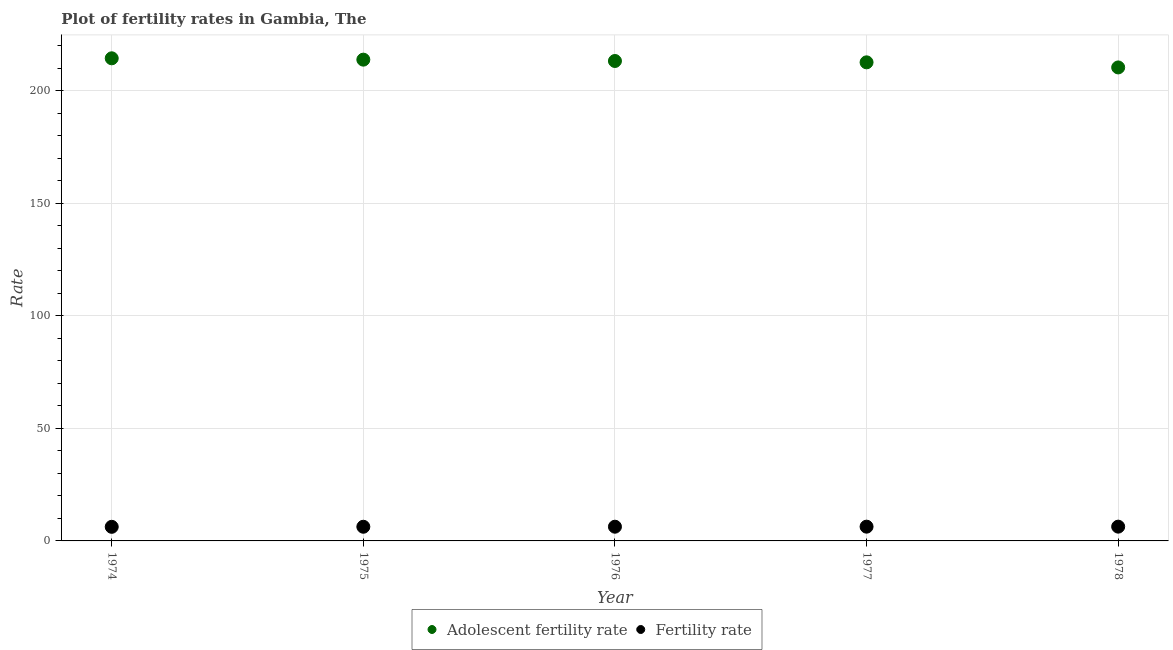How many different coloured dotlines are there?
Keep it short and to the point. 2. What is the adolescent fertility rate in 1975?
Ensure brevity in your answer.  213.81. Across all years, what is the maximum fertility rate?
Make the answer very short. 6.34. Across all years, what is the minimum adolescent fertility rate?
Ensure brevity in your answer.  210.35. In which year was the fertility rate maximum?
Keep it short and to the point. 1978. In which year was the adolescent fertility rate minimum?
Give a very brief answer. 1978. What is the total adolescent fertility rate in the graph?
Your answer should be compact. 1064.4. What is the difference between the fertility rate in 1975 and that in 1977?
Keep it short and to the point. -0.04. What is the difference between the fertility rate in 1975 and the adolescent fertility rate in 1976?
Keep it short and to the point. -206.92. What is the average fertility rate per year?
Your answer should be compact. 6.31. In the year 1978, what is the difference between the fertility rate and adolescent fertility rate?
Offer a very short reply. -204.01. What is the ratio of the fertility rate in 1976 to that in 1977?
Provide a short and direct response. 1. What is the difference between the highest and the second highest fertility rate?
Keep it short and to the point. 0.01. What is the difference between the highest and the lowest fertility rate?
Keep it short and to the point. 0.08. In how many years, is the adolescent fertility rate greater than the average adolescent fertility rate taken over all years?
Give a very brief answer. 3. Is the adolescent fertility rate strictly less than the fertility rate over the years?
Your answer should be very brief. No. What is the difference between two consecutive major ticks on the Y-axis?
Your answer should be compact. 50. Does the graph contain any zero values?
Provide a succinct answer. No. Does the graph contain grids?
Give a very brief answer. Yes. Where does the legend appear in the graph?
Provide a succinct answer. Bottom center. How are the legend labels stacked?
Offer a very short reply. Horizontal. What is the title of the graph?
Offer a terse response. Plot of fertility rates in Gambia, The. What is the label or title of the X-axis?
Give a very brief answer. Year. What is the label or title of the Y-axis?
Your answer should be very brief. Rate. What is the Rate of Adolescent fertility rate in 1974?
Your answer should be compact. 214.41. What is the Rate in Fertility rate in 1974?
Offer a terse response. 6.26. What is the Rate of Adolescent fertility rate in 1975?
Your answer should be very brief. 213.81. What is the Rate in Fertility rate in 1975?
Ensure brevity in your answer.  6.29. What is the Rate in Adolescent fertility rate in 1976?
Provide a short and direct response. 213.21. What is the Rate of Fertility rate in 1976?
Provide a short and direct response. 6.32. What is the Rate of Adolescent fertility rate in 1977?
Provide a short and direct response. 212.62. What is the Rate in Fertility rate in 1977?
Give a very brief answer. 6.33. What is the Rate in Adolescent fertility rate in 1978?
Offer a very short reply. 210.35. What is the Rate of Fertility rate in 1978?
Offer a very short reply. 6.34. Across all years, what is the maximum Rate of Adolescent fertility rate?
Make the answer very short. 214.41. Across all years, what is the maximum Rate of Fertility rate?
Ensure brevity in your answer.  6.34. Across all years, what is the minimum Rate of Adolescent fertility rate?
Provide a short and direct response. 210.35. Across all years, what is the minimum Rate of Fertility rate?
Your answer should be very brief. 6.26. What is the total Rate of Adolescent fertility rate in the graph?
Your answer should be compact. 1064.4. What is the total Rate of Fertility rate in the graph?
Your answer should be compact. 31.55. What is the difference between the Rate of Adolescent fertility rate in 1974 and that in 1975?
Your response must be concise. 0.6. What is the difference between the Rate of Fertility rate in 1974 and that in 1975?
Provide a short and direct response. -0.03. What is the difference between the Rate in Adolescent fertility rate in 1974 and that in 1976?
Provide a short and direct response. 1.2. What is the difference between the Rate in Fertility rate in 1974 and that in 1976?
Provide a short and direct response. -0.05. What is the difference between the Rate in Adolescent fertility rate in 1974 and that in 1977?
Offer a terse response. 1.79. What is the difference between the Rate in Fertility rate in 1974 and that in 1977?
Your response must be concise. -0.07. What is the difference between the Rate in Adolescent fertility rate in 1974 and that in 1978?
Provide a short and direct response. 4.06. What is the difference between the Rate of Fertility rate in 1974 and that in 1978?
Your answer should be very brief. -0.08. What is the difference between the Rate in Adolescent fertility rate in 1975 and that in 1976?
Provide a short and direct response. 0.6. What is the difference between the Rate in Fertility rate in 1975 and that in 1976?
Offer a very short reply. -0.02. What is the difference between the Rate of Adolescent fertility rate in 1975 and that in 1977?
Your response must be concise. 1.2. What is the difference between the Rate of Fertility rate in 1975 and that in 1977?
Your answer should be very brief. -0.04. What is the difference between the Rate in Adolescent fertility rate in 1975 and that in 1978?
Ensure brevity in your answer.  3.46. What is the difference between the Rate in Fertility rate in 1975 and that in 1978?
Make the answer very short. -0.05. What is the difference between the Rate of Adolescent fertility rate in 1976 and that in 1977?
Keep it short and to the point. 0.6. What is the difference between the Rate of Fertility rate in 1976 and that in 1977?
Your answer should be compact. -0.02. What is the difference between the Rate in Adolescent fertility rate in 1976 and that in 1978?
Ensure brevity in your answer.  2.86. What is the difference between the Rate in Fertility rate in 1976 and that in 1978?
Provide a short and direct response. -0.03. What is the difference between the Rate in Adolescent fertility rate in 1977 and that in 1978?
Your answer should be very brief. 2.26. What is the difference between the Rate in Fertility rate in 1977 and that in 1978?
Keep it short and to the point. -0.01. What is the difference between the Rate in Adolescent fertility rate in 1974 and the Rate in Fertility rate in 1975?
Keep it short and to the point. 208.12. What is the difference between the Rate of Adolescent fertility rate in 1974 and the Rate of Fertility rate in 1976?
Your response must be concise. 208.09. What is the difference between the Rate in Adolescent fertility rate in 1974 and the Rate in Fertility rate in 1977?
Your answer should be compact. 208.08. What is the difference between the Rate in Adolescent fertility rate in 1974 and the Rate in Fertility rate in 1978?
Your answer should be compact. 208.07. What is the difference between the Rate of Adolescent fertility rate in 1975 and the Rate of Fertility rate in 1976?
Offer a very short reply. 207.49. What is the difference between the Rate in Adolescent fertility rate in 1975 and the Rate in Fertility rate in 1977?
Ensure brevity in your answer.  207.48. What is the difference between the Rate of Adolescent fertility rate in 1975 and the Rate of Fertility rate in 1978?
Your response must be concise. 207.47. What is the difference between the Rate in Adolescent fertility rate in 1976 and the Rate in Fertility rate in 1977?
Offer a very short reply. 206.88. What is the difference between the Rate in Adolescent fertility rate in 1976 and the Rate in Fertility rate in 1978?
Provide a succinct answer. 206.87. What is the difference between the Rate of Adolescent fertility rate in 1977 and the Rate of Fertility rate in 1978?
Your answer should be compact. 206.27. What is the average Rate in Adolescent fertility rate per year?
Provide a succinct answer. 212.88. What is the average Rate of Fertility rate per year?
Provide a short and direct response. 6.31. In the year 1974, what is the difference between the Rate in Adolescent fertility rate and Rate in Fertility rate?
Provide a succinct answer. 208.15. In the year 1975, what is the difference between the Rate of Adolescent fertility rate and Rate of Fertility rate?
Provide a succinct answer. 207.52. In the year 1976, what is the difference between the Rate in Adolescent fertility rate and Rate in Fertility rate?
Provide a short and direct response. 206.9. In the year 1977, what is the difference between the Rate in Adolescent fertility rate and Rate in Fertility rate?
Make the answer very short. 206.28. In the year 1978, what is the difference between the Rate in Adolescent fertility rate and Rate in Fertility rate?
Make the answer very short. 204.01. What is the ratio of the Rate in Adolescent fertility rate in 1974 to that in 1976?
Offer a terse response. 1.01. What is the ratio of the Rate in Adolescent fertility rate in 1974 to that in 1977?
Offer a terse response. 1.01. What is the ratio of the Rate in Fertility rate in 1974 to that in 1977?
Make the answer very short. 0.99. What is the ratio of the Rate of Adolescent fertility rate in 1974 to that in 1978?
Offer a terse response. 1.02. What is the ratio of the Rate of Fertility rate in 1974 to that in 1978?
Provide a short and direct response. 0.99. What is the ratio of the Rate in Adolescent fertility rate in 1975 to that in 1976?
Your answer should be very brief. 1. What is the ratio of the Rate in Fertility rate in 1975 to that in 1976?
Give a very brief answer. 1. What is the ratio of the Rate in Adolescent fertility rate in 1975 to that in 1977?
Your answer should be compact. 1.01. What is the ratio of the Rate in Fertility rate in 1975 to that in 1977?
Ensure brevity in your answer.  0.99. What is the ratio of the Rate of Adolescent fertility rate in 1975 to that in 1978?
Give a very brief answer. 1.02. What is the ratio of the Rate of Fertility rate in 1975 to that in 1978?
Make the answer very short. 0.99. What is the ratio of the Rate in Adolescent fertility rate in 1976 to that in 1977?
Provide a short and direct response. 1. What is the ratio of the Rate of Adolescent fertility rate in 1976 to that in 1978?
Ensure brevity in your answer.  1.01. What is the ratio of the Rate of Adolescent fertility rate in 1977 to that in 1978?
Offer a very short reply. 1.01. What is the difference between the highest and the second highest Rate in Adolescent fertility rate?
Keep it short and to the point. 0.6. What is the difference between the highest and the second highest Rate of Fertility rate?
Your answer should be very brief. 0.01. What is the difference between the highest and the lowest Rate in Adolescent fertility rate?
Your answer should be very brief. 4.06. What is the difference between the highest and the lowest Rate of Fertility rate?
Provide a succinct answer. 0.08. 